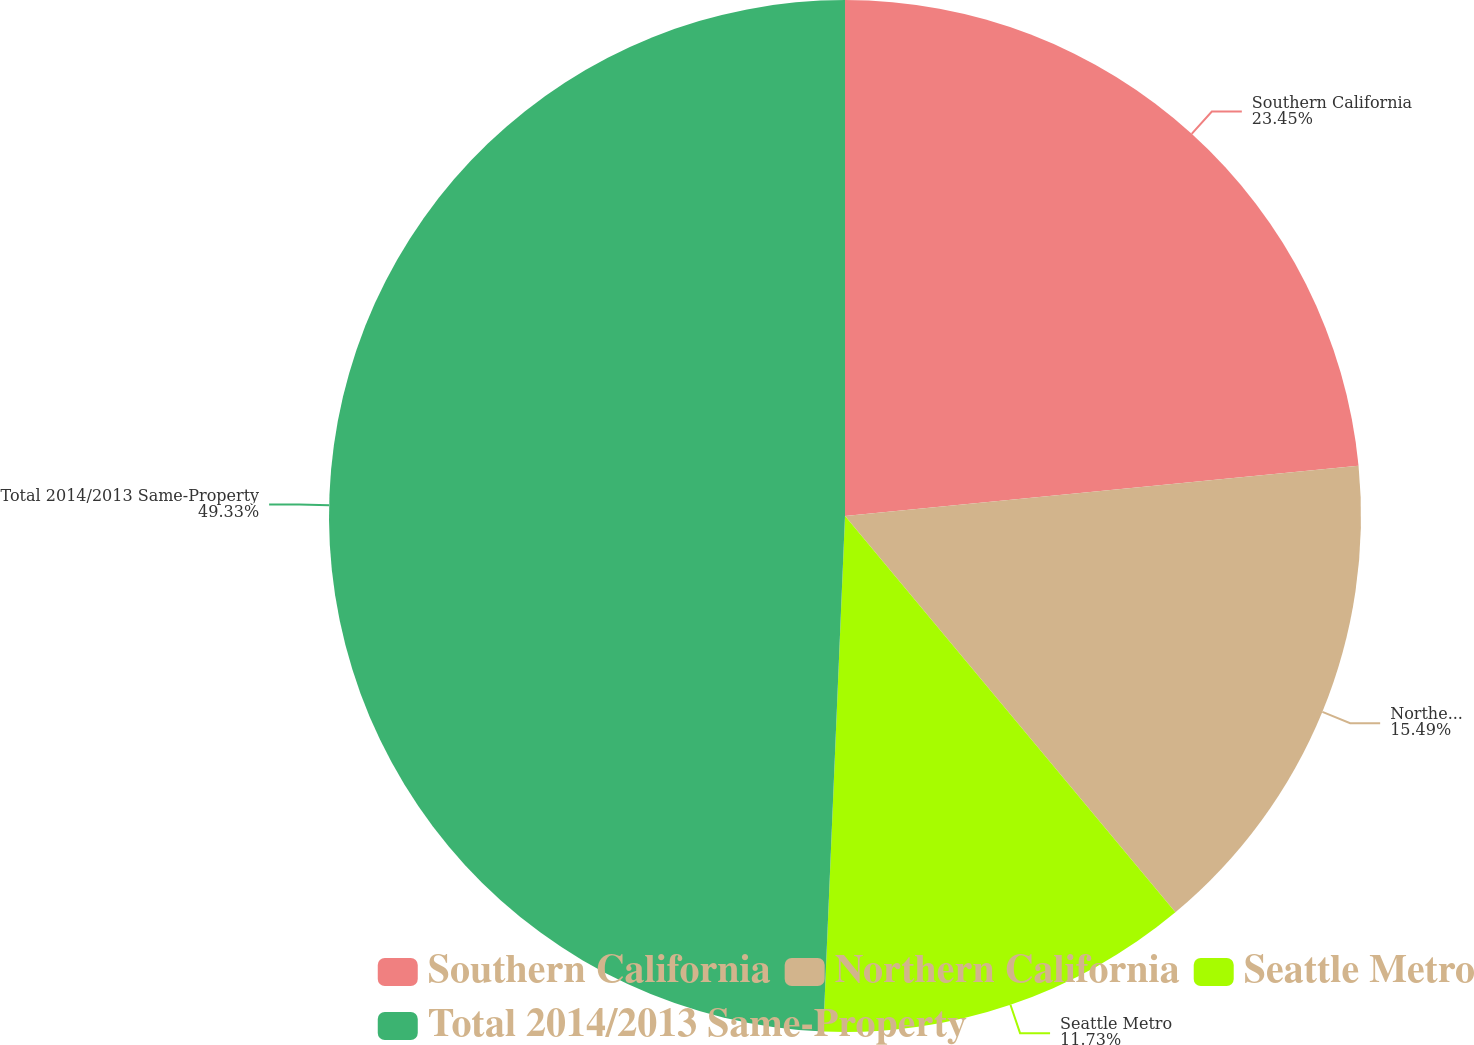<chart> <loc_0><loc_0><loc_500><loc_500><pie_chart><fcel>Southern California<fcel>Northern California<fcel>Seattle Metro<fcel>Total 2014/2013 Same-Property<nl><fcel>23.45%<fcel>15.49%<fcel>11.73%<fcel>49.33%<nl></chart> 